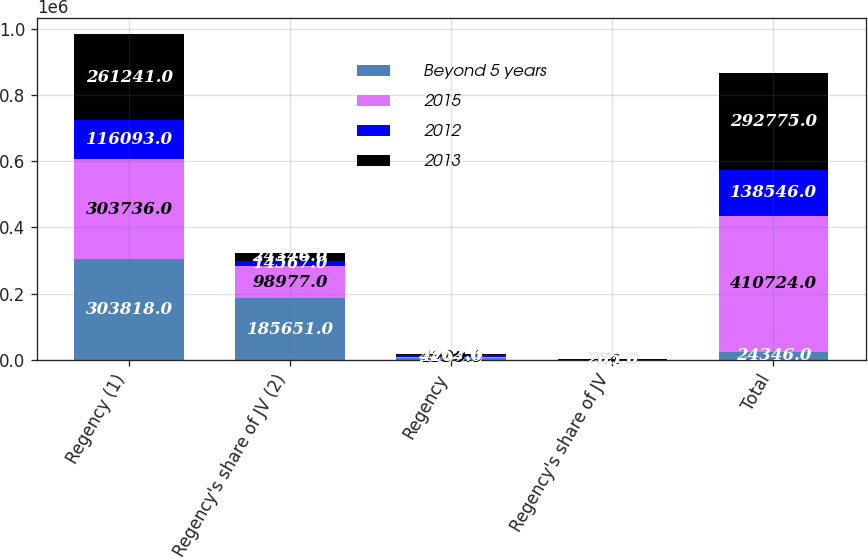Convert chart to OTSL. <chart><loc_0><loc_0><loc_500><loc_500><stacked_bar_chart><ecel><fcel>Regency (1)<fcel>Regency's share of JV (2)<fcel>Regency<fcel>Regency's share of JV<fcel>Total<nl><fcel>Beyond 5 years<fcel>303818<fcel>185651<fcel>4695<fcel>264<fcel>24346<nl><fcel>2015<fcel>303736<fcel>98977<fcel>4390<fcel>264<fcel>410724<nl><fcel>2012<fcel>116093<fcel>14567<fcel>4267<fcel>265<fcel>138546<nl><fcel>2013<fcel>261241<fcel>24346<fcel>3562<fcel>265<fcel>292775<nl></chart> 